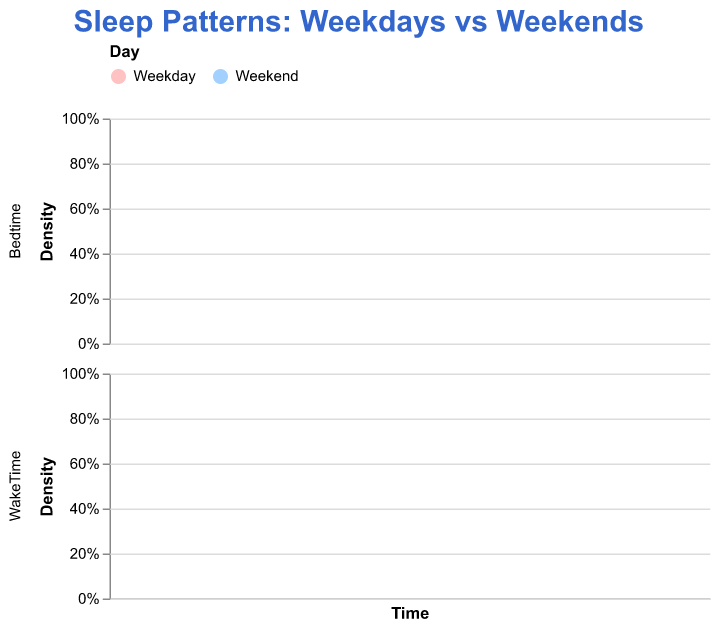How does the distribution of bedtimes differ between weekdays and weekends? Look at the bedtime density plot. The weekday distribution is more concentrated around earlier times (e.g., 22:00 to 23:30), while the weekend distribution is more spread out and shifted towards later times (e.g., 23:00 to 01:00).
Answer: Bedtimes are earlier on weekdays and later on weekends What is the most common wake-up time on weekends? Examine the peak of the wake time density plot for weekends. The peak is around 08:00 to 10:00.
Answer: Around 09:00 Does the density plot show more early risers on weekdays or weekends? Look at the wake time density plot. The density is higher earlier (around 06:00 to 07:30) on weekdays than on weekends.
Answer: Weekdays Which day type has a more uniform distribution of wake times? Observe the spread of the wake time densities across all times. The weekend distribution is more spread out, indicating a more uniform distribution.
Answer: Weekends Are there any overlaps in bedtime distributions for weekdays and weekends? The bedtime density plots for weekdays and weekends do overlap, particularly between 22:00 and 23:30.
Answer: Yes What is the general trend in wake-up times on weekends compared to weekdays? Compare the density plots of wake times. Weekends show a later general trend in wake-up times than weekdays.
Answer: Later wake-up times on weekends What specific times have the highest density for wake-ups on weekdays? Look at the peak in the weekday wake time density plot. It is around 06:00 to 07:30.
Answer: Around 06:30 Do more people go to bed after midnight on weekends or weekdays? Compare density plots of bedtimes on weekdays and weekends. The weekend plot has a higher density after midnight than the weekday plot.
Answer: Weekends How does the bedtime density for Michael Johnson compare on weekdays versus weekends? Observe Michael Johnson's data on the density plots. For weekdays, his bedtime is consistently earlier around 22:00, while on weekends, it's 23:00.
Answer: Earlier on weekdays (22:00) vs. 23:00 on weekends Is there a noticeable shift in both bedtime and wake time distributions from weekdays to weekends for Pippa Britton? Find Pippa Britton's data and compare her weekday and weekend bedtimes and wake times. Her bedtime and wake time both shift to later times on weekends.
Answer: Yes, later bedtime and wake time on weekends 